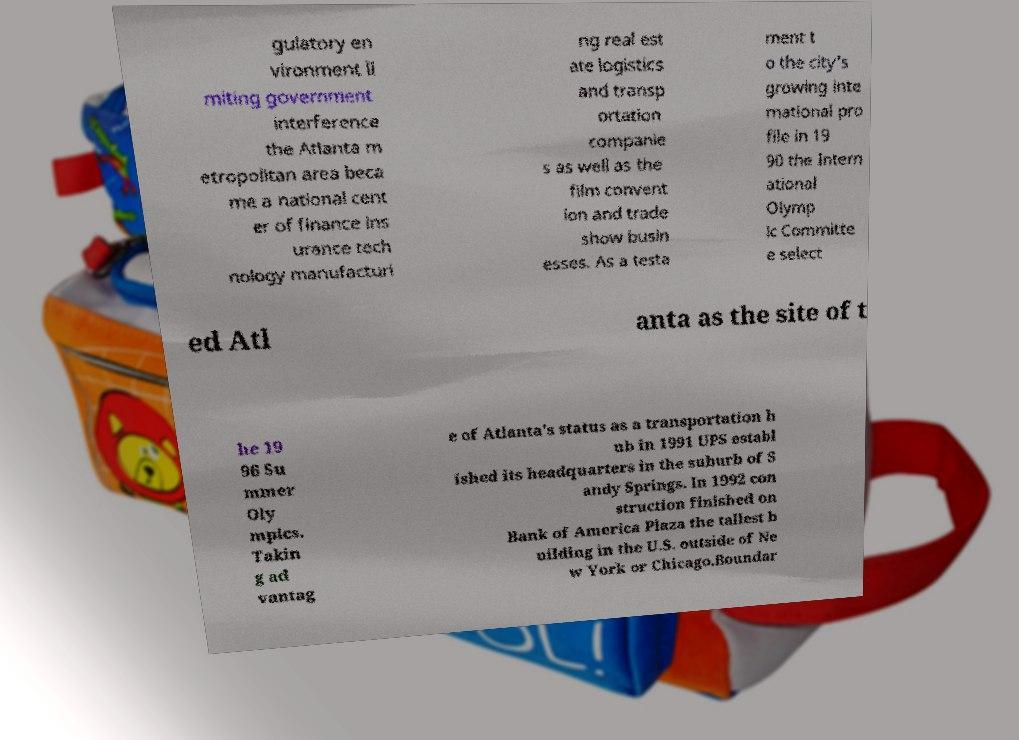There's text embedded in this image that I need extracted. Can you transcribe it verbatim? gulatory en vironment li miting government interference the Atlanta m etropolitan area beca me a national cent er of finance ins urance tech nology manufacturi ng real est ate logistics and transp ortation companie s as well as the film convent ion and trade show busin esses. As a testa ment t o the city's growing inte rnational pro file in 19 90 the Intern ational Olymp ic Committe e select ed Atl anta as the site of t he 19 96 Su mmer Oly mpics. Takin g ad vantag e of Atlanta's status as a transportation h ub in 1991 UPS establ ished its headquarters in the suburb of S andy Springs. In 1992 con struction finished on Bank of America Plaza the tallest b uilding in the U.S. outside of Ne w York or Chicago.Boundar 